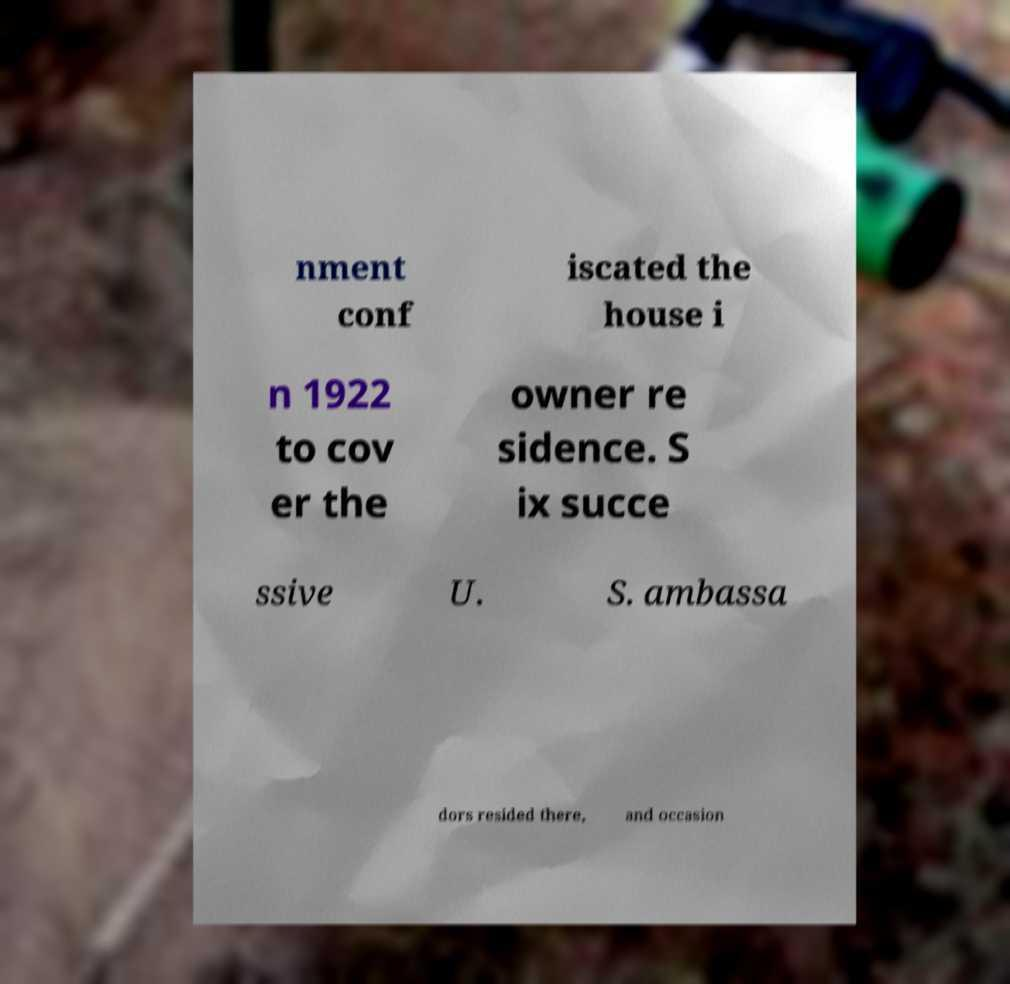For documentation purposes, I need the text within this image transcribed. Could you provide that? nment conf iscated the house i n 1922 to cov er the owner re sidence. S ix succe ssive U. S. ambassa dors resided there, and occasion 